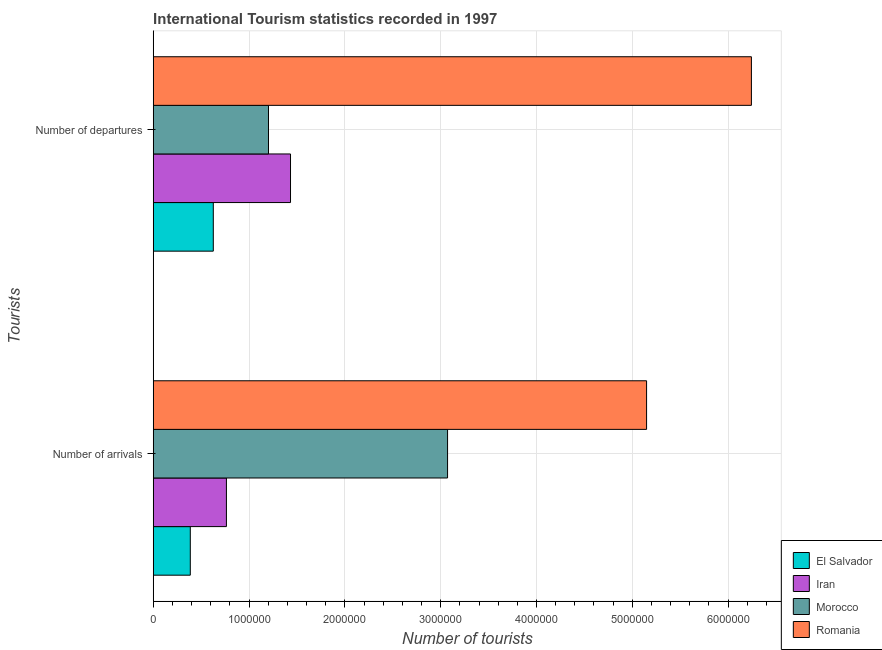Are the number of bars on each tick of the Y-axis equal?
Your response must be concise. Yes. How many bars are there on the 2nd tick from the top?
Your answer should be compact. 4. What is the label of the 2nd group of bars from the top?
Your response must be concise. Number of arrivals. What is the number of tourist arrivals in Iran?
Your answer should be compact. 7.64e+05. Across all countries, what is the maximum number of tourist arrivals?
Your answer should be compact. 5.15e+06. Across all countries, what is the minimum number of tourist arrivals?
Your answer should be compact. 3.87e+05. In which country was the number of tourist arrivals maximum?
Your answer should be compact. Romania. In which country was the number of tourist departures minimum?
Your answer should be very brief. El Salvador. What is the total number of tourist departures in the graph?
Your answer should be very brief. 9.51e+06. What is the difference between the number of tourist arrivals in El Salvador and that in Romania?
Keep it short and to the point. -4.76e+06. What is the difference between the number of tourist departures in Romania and the number of tourist arrivals in Morocco?
Your response must be concise. 3.17e+06. What is the average number of tourist arrivals per country?
Make the answer very short. 2.34e+06. What is the difference between the number of tourist departures and number of tourist arrivals in El Salvador?
Ensure brevity in your answer.  2.40e+05. What is the ratio of the number of tourist departures in Romania to that in Morocco?
Your answer should be very brief. 5.19. What does the 2nd bar from the top in Number of departures represents?
Offer a terse response. Morocco. What does the 1st bar from the bottom in Number of arrivals represents?
Provide a short and direct response. El Salvador. Are all the bars in the graph horizontal?
Your answer should be compact. Yes. Does the graph contain grids?
Give a very brief answer. Yes. How are the legend labels stacked?
Offer a terse response. Vertical. What is the title of the graph?
Offer a very short reply. International Tourism statistics recorded in 1997. Does "Serbia" appear as one of the legend labels in the graph?
Give a very brief answer. No. What is the label or title of the X-axis?
Your response must be concise. Number of tourists. What is the label or title of the Y-axis?
Keep it short and to the point. Tourists. What is the Number of tourists in El Salvador in Number of arrivals?
Provide a succinct answer. 3.87e+05. What is the Number of tourists in Iran in Number of arrivals?
Offer a terse response. 7.64e+05. What is the Number of tourists in Morocco in Number of arrivals?
Give a very brief answer. 3.07e+06. What is the Number of tourists in Romania in Number of arrivals?
Give a very brief answer. 5.15e+06. What is the Number of tourists in El Salvador in Number of departures?
Offer a very short reply. 6.27e+05. What is the Number of tourists of Iran in Number of departures?
Give a very brief answer. 1.43e+06. What is the Number of tourists of Morocco in Number of departures?
Ensure brevity in your answer.  1.20e+06. What is the Number of tourists in Romania in Number of departures?
Give a very brief answer. 6.24e+06. Across all Tourists, what is the maximum Number of tourists of El Salvador?
Your response must be concise. 6.27e+05. Across all Tourists, what is the maximum Number of tourists in Iran?
Offer a terse response. 1.43e+06. Across all Tourists, what is the maximum Number of tourists in Morocco?
Give a very brief answer. 3.07e+06. Across all Tourists, what is the maximum Number of tourists of Romania?
Your answer should be compact. 6.24e+06. Across all Tourists, what is the minimum Number of tourists of El Salvador?
Offer a very short reply. 3.87e+05. Across all Tourists, what is the minimum Number of tourists in Iran?
Provide a succinct answer. 7.64e+05. Across all Tourists, what is the minimum Number of tourists of Morocco?
Ensure brevity in your answer.  1.20e+06. Across all Tourists, what is the minimum Number of tourists of Romania?
Your response must be concise. 5.15e+06. What is the total Number of tourists of El Salvador in the graph?
Keep it short and to the point. 1.01e+06. What is the total Number of tourists of Iran in the graph?
Provide a short and direct response. 2.20e+06. What is the total Number of tourists of Morocco in the graph?
Offer a terse response. 4.28e+06. What is the total Number of tourists of Romania in the graph?
Give a very brief answer. 1.14e+07. What is the difference between the Number of tourists of Iran in Number of arrivals and that in Number of departures?
Give a very brief answer. -6.69e+05. What is the difference between the Number of tourists of Morocco in Number of arrivals and that in Number of departures?
Your answer should be compact. 1.87e+06. What is the difference between the Number of tourists in Romania in Number of arrivals and that in Number of departures?
Give a very brief answer. -1.09e+06. What is the difference between the Number of tourists of El Salvador in Number of arrivals and the Number of tourists of Iran in Number of departures?
Give a very brief answer. -1.05e+06. What is the difference between the Number of tourists in El Salvador in Number of arrivals and the Number of tourists in Morocco in Number of departures?
Offer a terse response. -8.16e+05. What is the difference between the Number of tourists in El Salvador in Number of arrivals and the Number of tourists in Romania in Number of departures?
Your response must be concise. -5.86e+06. What is the difference between the Number of tourists in Iran in Number of arrivals and the Number of tourists in Morocco in Number of departures?
Provide a short and direct response. -4.39e+05. What is the difference between the Number of tourists in Iran in Number of arrivals and the Number of tourists in Romania in Number of departures?
Your answer should be very brief. -5.48e+06. What is the difference between the Number of tourists in Morocco in Number of arrivals and the Number of tourists in Romania in Number of departures?
Offer a very short reply. -3.17e+06. What is the average Number of tourists in El Salvador per Tourists?
Provide a short and direct response. 5.07e+05. What is the average Number of tourists of Iran per Tourists?
Make the answer very short. 1.10e+06. What is the average Number of tourists of Morocco per Tourists?
Offer a terse response. 2.14e+06. What is the average Number of tourists in Romania per Tourists?
Your answer should be compact. 5.70e+06. What is the difference between the Number of tourists in El Salvador and Number of tourists in Iran in Number of arrivals?
Ensure brevity in your answer.  -3.77e+05. What is the difference between the Number of tourists in El Salvador and Number of tourists in Morocco in Number of arrivals?
Provide a short and direct response. -2.68e+06. What is the difference between the Number of tourists of El Salvador and Number of tourists of Romania in Number of arrivals?
Ensure brevity in your answer.  -4.76e+06. What is the difference between the Number of tourists in Iran and Number of tourists in Morocco in Number of arrivals?
Make the answer very short. -2.31e+06. What is the difference between the Number of tourists of Iran and Number of tourists of Romania in Number of arrivals?
Your response must be concise. -4.38e+06. What is the difference between the Number of tourists of Morocco and Number of tourists of Romania in Number of arrivals?
Make the answer very short. -2.08e+06. What is the difference between the Number of tourists in El Salvador and Number of tourists in Iran in Number of departures?
Keep it short and to the point. -8.06e+05. What is the difference between the Number of tourists in El Salvador and Number of tourists in Morocco in Number of departures?
Your response must be concise. -5.76e+05. What is the difference between the Number of tourists in El Salvador and Number of tourists in Romania in Number of departures?
Keep it short and to the point. -5.62e+06. What is the difference between the Number of tourists of Iran and Number of tourists of Romania in Number of departures?
Keep it short and to the point. -4.81e+06. What is the difference between the Number of tourists of Morocco and Number of tourists of Romania in Number of departures?
Make the answer very short. -5.04e+06. What is the ratio of the Number of tourists of El Salvador in Number of arrivals to that in Number of departures?
Your answer should be compact. 0.62. What is the ratio of the Number of tourists in Iran in Number of arrivals to that in Number of departures?
Your response must be concise. 0.53. What is the ratio of the Number of tourists in Morocco in Number of arrivals to that in Number of departures?
Your response must be concise. 2.55. What is the ratio of the Number of tourists of Romania in Number of arrivals to that in Number of departures?
Provide a short and direct response. 0.82. What is the difference between the highest and the second highest Number of tourists in El Salvador?
Offer a very short reply. 2.40e+05. What is the difference between the highest and the second highest Number of tourists of Iran?
Offer a very short reply. 6.69e+05. What is the difference between the highest and the second highest Number of tourists in Morocco?
Keep it short and to the point. 1.87e+06. What is the difference between the highest and the second highest Number of tourists of Romania?
Your answer should be very brief. 1.09e+06. What is the difference between the highest and the lowest Number of tourists of Iran?
Offer a terse response. 6.69e+05. What is the difference between the highest and the lowest Number of tourists in Morocco?
Provide a succinct answer. 1.87e+06. What is the difference between the highest and the lowest Number of tourists of Romania?
Keep it short and to the point. 1.09e+06. 